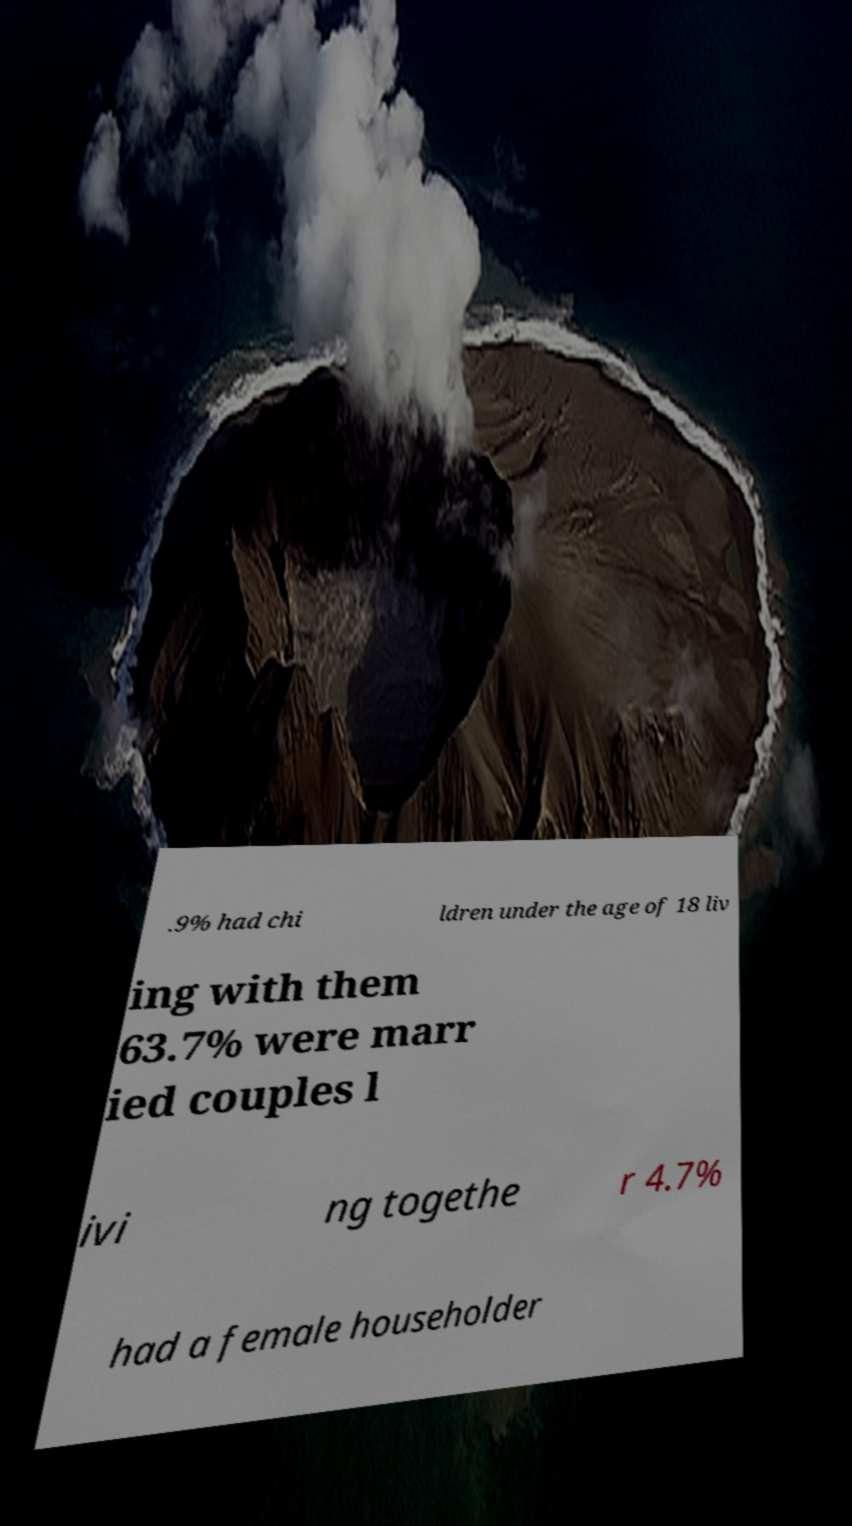Please identify and transcribe the text found in this image. .9% had chi ldren under the age of 18 liv ing with them 63.7% were marr ied couples l ivi ng togethe r 4.7% had a female householder 